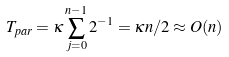<formula> <loc_0><loc_0><loc_500><loc_500>T _ { p a r } = \kappa \sum _ { j = 0 } ^ { n - 1 } 2 ^ { - 1 } = \kappa n / 2 \approx O ( n )</formula> 